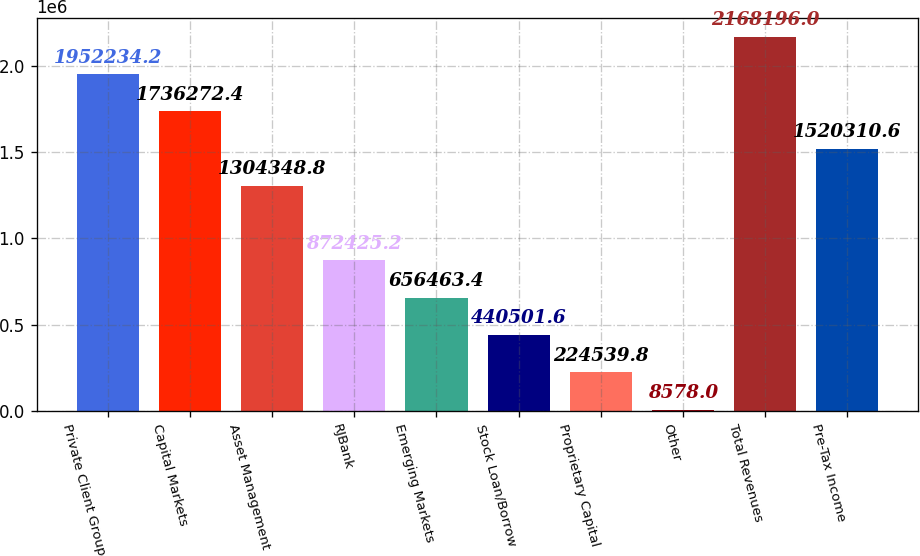Convert chart to OTSL. <chart><loc_0><loc_0><loc_500><loc_500><bar_chart><fcel>Private Client Group<fcel>Capital Markets<fcel>Asset Management<fcel>RJBank<fcel>Emerging Markets<fcel>Stock Loan/Borrow<fcel>Proprietary Capital<fcel>Other<fcel>Total Revenues<fcel>Pre-Tax Income<nl><fcel>1.95223e+06<fcel>1.73627e+06<fcel>1.30435e+06<fcel>872425<fcel>656463<fcel>440502<fcel>224540<fcel>8578<fcel>2.1682e+06<fcel>1.52031e+06<nl></chart> 